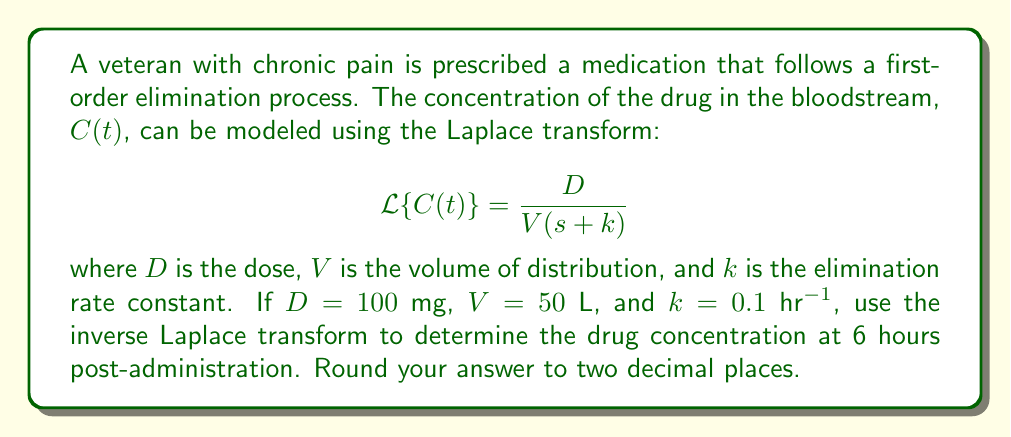Provide a solution to this math problem. To solve this problem, we need to follow these steps:

1) We are given the Laplace transform of the concentration function:

   $$\mathcal{L}\{C(t)\} = \frac{D}{V(s + k)}$$

2) Substituting the given values:

   $$\mathcal{L}\{C(t)\} = \frac{100}{50(s + 0.1)} = \frac{2}{s + 0.1}$$

3) To find $C(t)$, we need to apply the inverse Laplace transform. This transform is of the form:

   $$\mathcal{L}^{-1}\{\frac{a}{s + b}\} = ae^{-bt}$$

4) In our case, $a = 2$ and $b = 0.1$. Therefore:

   $$C(t) = 2e^{-0.1t}$$

5) To find the concentration at 6 hours, we substitute $t = 6$:

   $$C(6) = 2e^{-0.1(6)} = 2e^{-0.6}$$

6) Calculating this value:

   $$C(6) = 2 * 0.5488 = 1.0976$$

7) Rounding to two decimal places:

   $$C(6) \approx 1.10$$
Answer: $1.10$ mg/L 